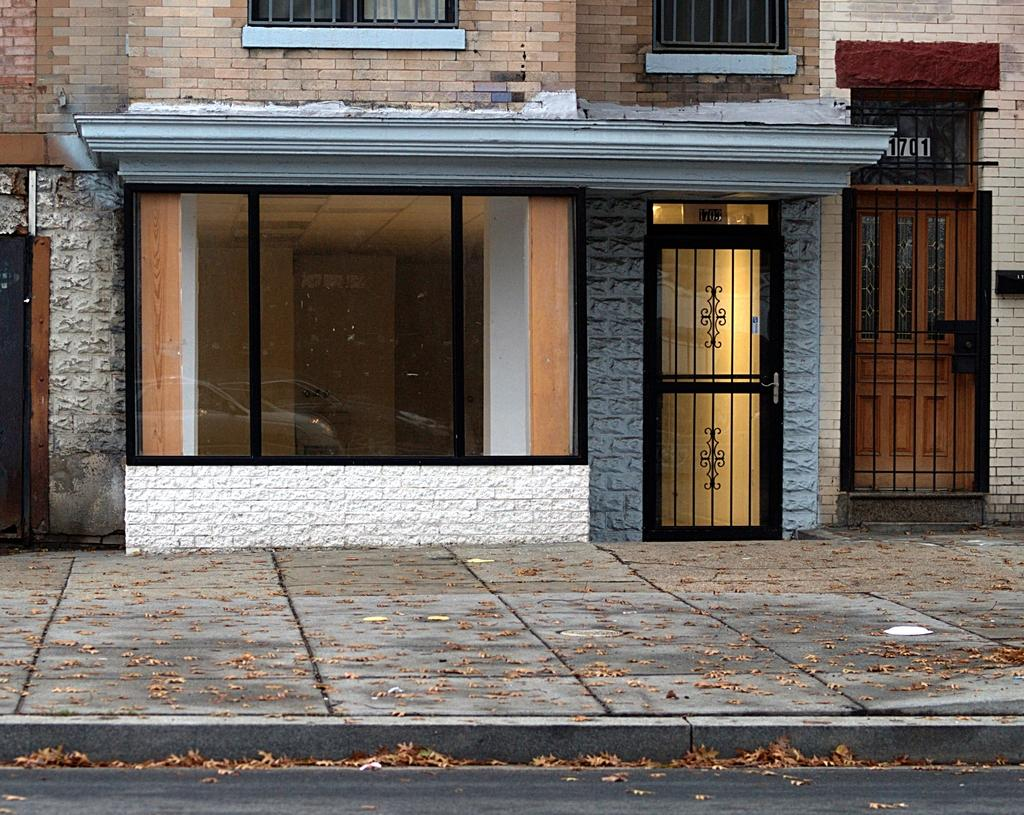What type of structure is visible in the image? There is a building in the image. What features can be seen on the building? The building has windows and doors. What is located in front of the building? There is a pavement in front of the building. What is present on the pavement? Dried leaves are present on the pavement. What is visible at the bottom of the image? There is a road at the bottom of the image. What type of cord is hanging from the building in the image? There is no cord hanging from the building in the image. What is the heat level in the image? The image does not provide information about the heat level; it only shows a building, pavement, and road. 